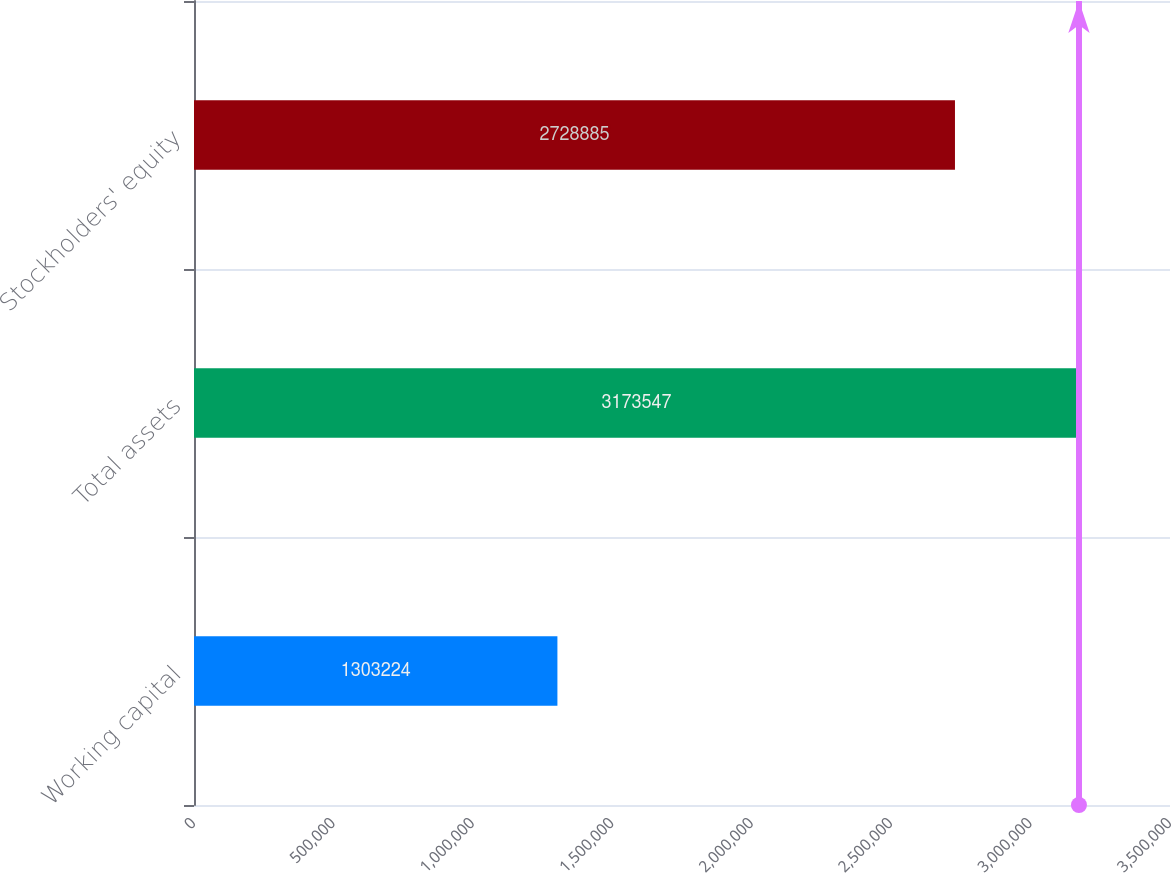Convert chart. <chart><loc_0><loc_0><loc_500><loc_500><bar_chart><fcel>Working capital<fcel>Total assets<fcel>Stockholders' equity<nl><fcel>1.30322e+06<fcel>3.17355e+06<fcel>2.72888e+06<nl></chart> 